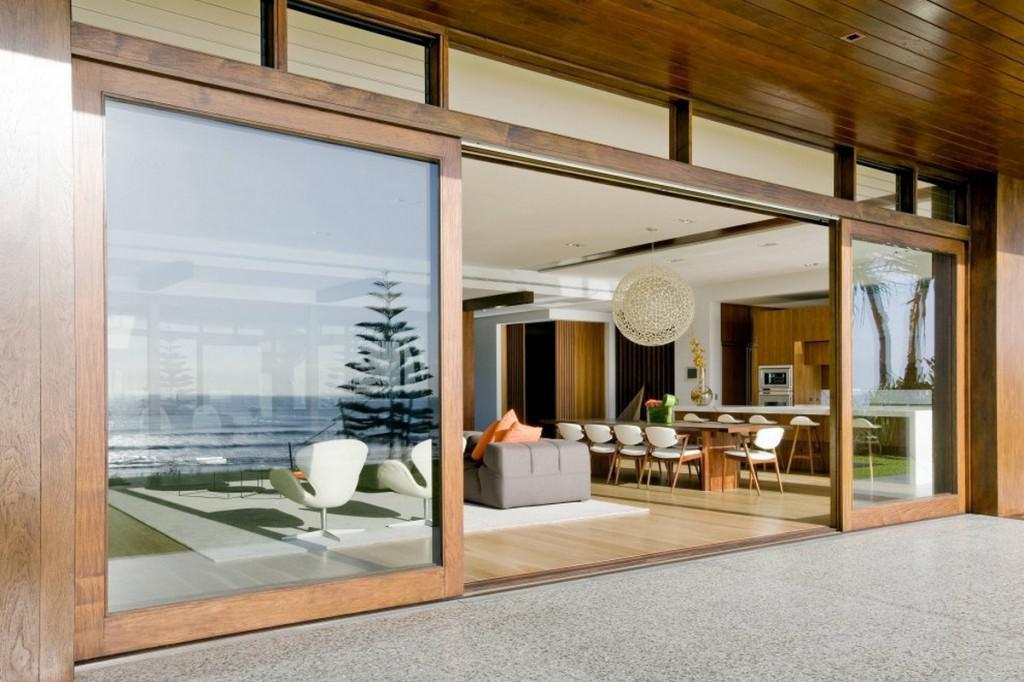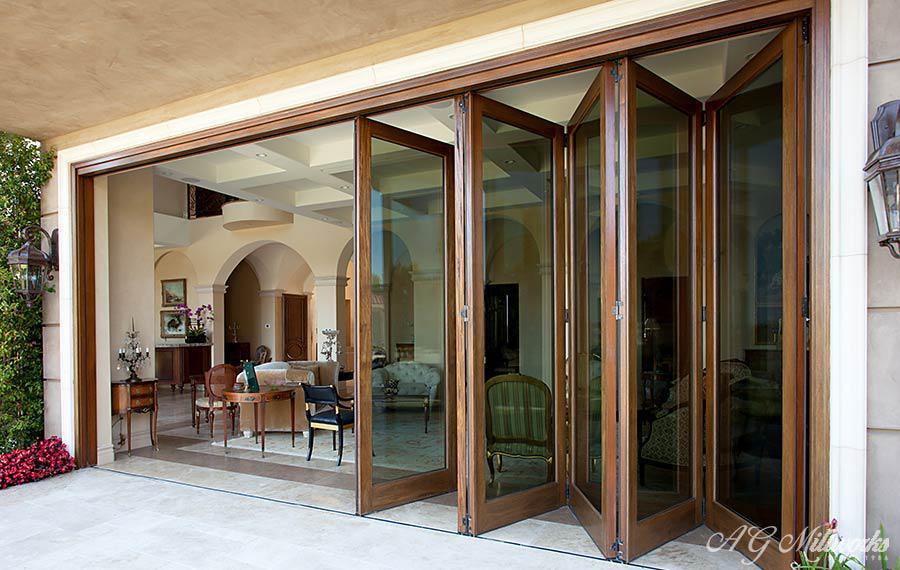The first image is the image on the left, the second image is the image on the right. Assess this claim about the two images: "There is a flower vase on top of a table near a sliding door.". Correct or not? Answer yes or no. No. 